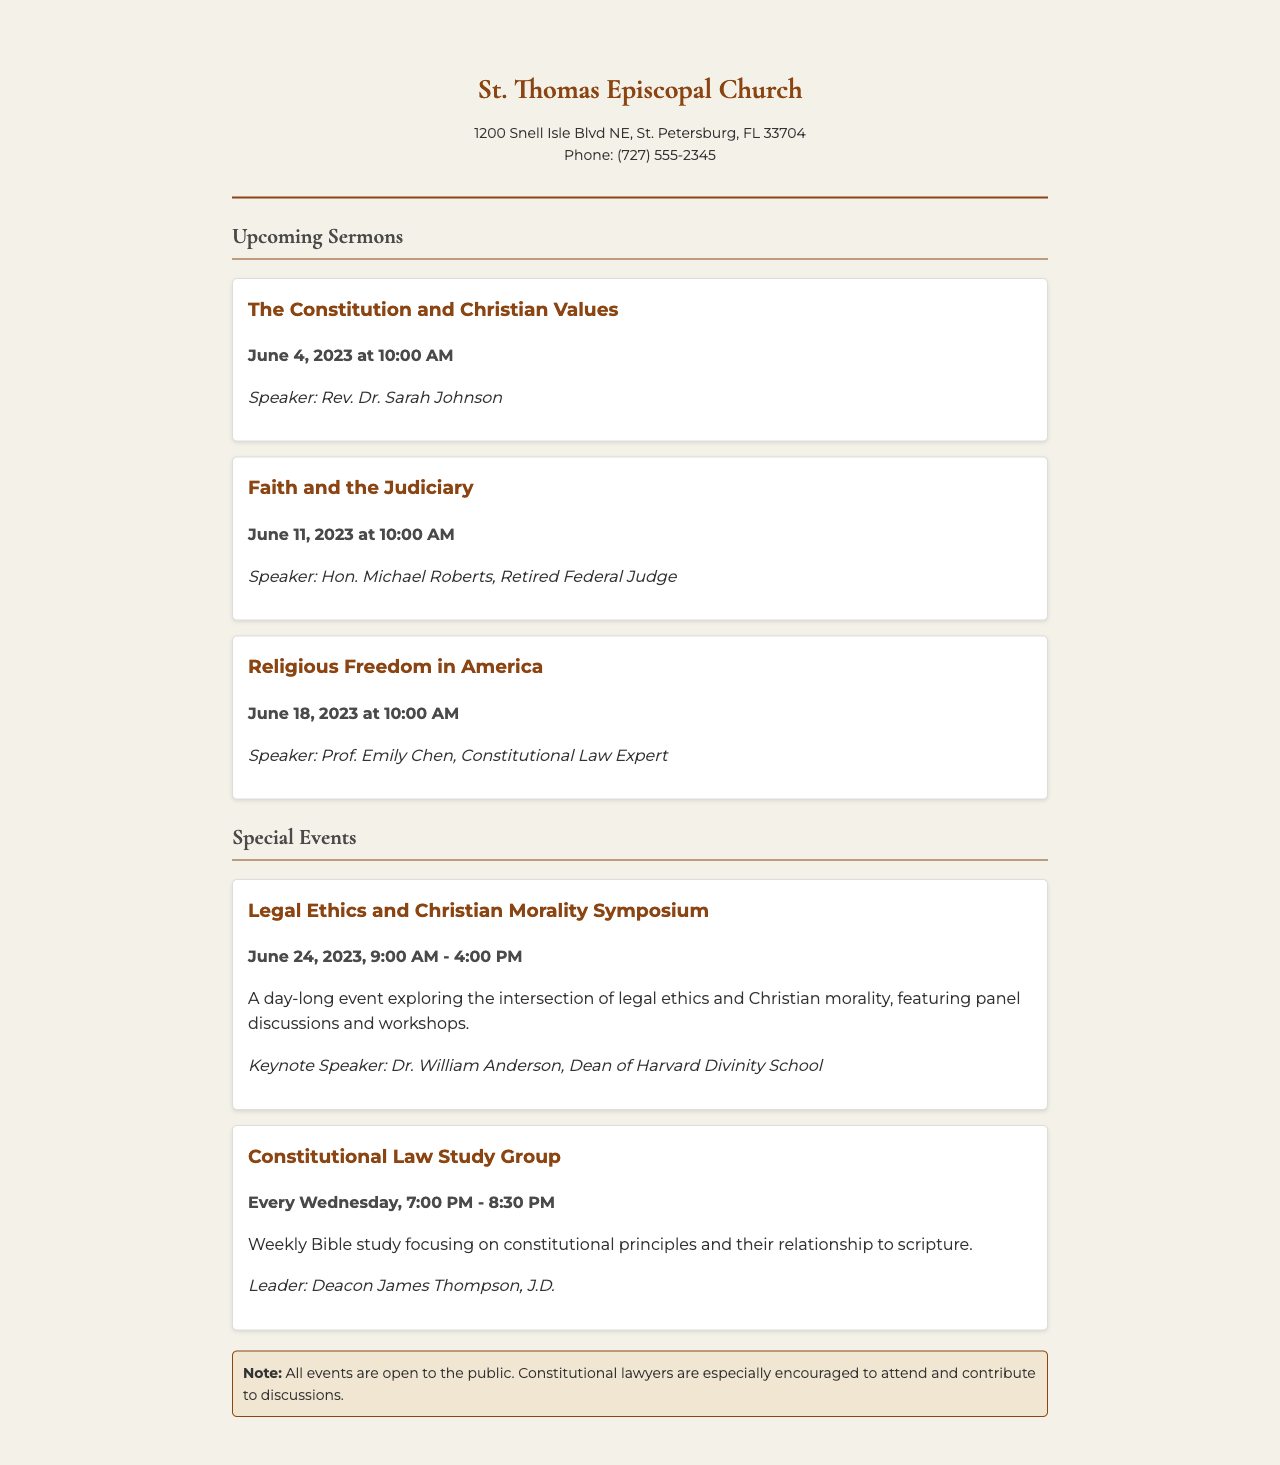What is the title of the sermon on June 4, 2023? The title is found in the section listing upcoming sermons.
Answer: The Constitution and Christian Values Who is the speaker for the sermon on June 11, 2023? The speaker information is provided with each sermon listing.
Answer: Hon. Michael Roberts, Retired Federal Judge What time does the sermon on June 18, 2023, start? The time is indicated as part of the date-time information for that sermon.
Answer: 10:00 AM What is the date for the Legal Ethics and Christian Morality Symposium? The date can be found in the special events section.
Answer: June 24, 2023 How often does the Constitutional Law Study Group meet? This information is stated in the study group's description.
Answer: Every Wednesday What type of event is scheduled for June 24, 2023? The description of the event provides this information.
Answer: Symposium Who is leading the Constitutional Law Study Group? The leader's name is mentioned in the group's details.
Answer: Deacon James Thompson, J.D What is the main focus of the Legal Ethics and Christian Morality Symposium? The symposium's focus is described in the details provided.
Answer: Intersection of legal ethics and Christian morality Are all events open to the public? This information is part of the note at the end of the document.
Answer: Yes 